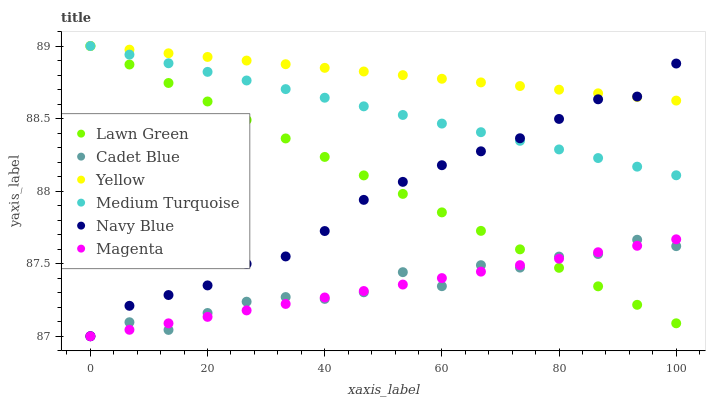Does Magenta have the minimum area under the curve?
Answer yes or no. Yes. Does Yellow have the maximum area under the curve?
Answer yes or no. Yes. Does Cadet Blue have the minimum area under the curve?
Answer yes or no. No. Does Cadet Blue have the maximum area under the curve?
Answer yes or no. No. Is Medium Turquoise the smoothest?
Answer yes or no. Yes. Is Cadet Blue the roughest?
Answer yes or no. Yes. Is Navy Blue the smoothest?
Answer yes or no. No. Is Navy Blue the roughest?
Answer yes or no. No. Does Cadet Blue have the lowest value?
Answer yes or no. Yes. Does Yellow have the lowest value?
Answer yes or no. No. Does Medium Turquoise have the highest value?
Answer yes or no. Yes. Does Navy Blue have the highest value?
Answer yes or no. No. Is Magenta less than Yellow?
Answer yes or no. Yes. Is Yellow greater than Cadet Blue?
Answer yes or no. Yes. Does Lawn Green intersect Magenta?
Answer yes or no. Yes. Is Lawn Green less than Magenta?
Answer yes or no. No. Is Lawn Green greater than Magenta?
Answer yes or no. No. Does Magenta intersect Yellow?
Answer yes or no. No. 